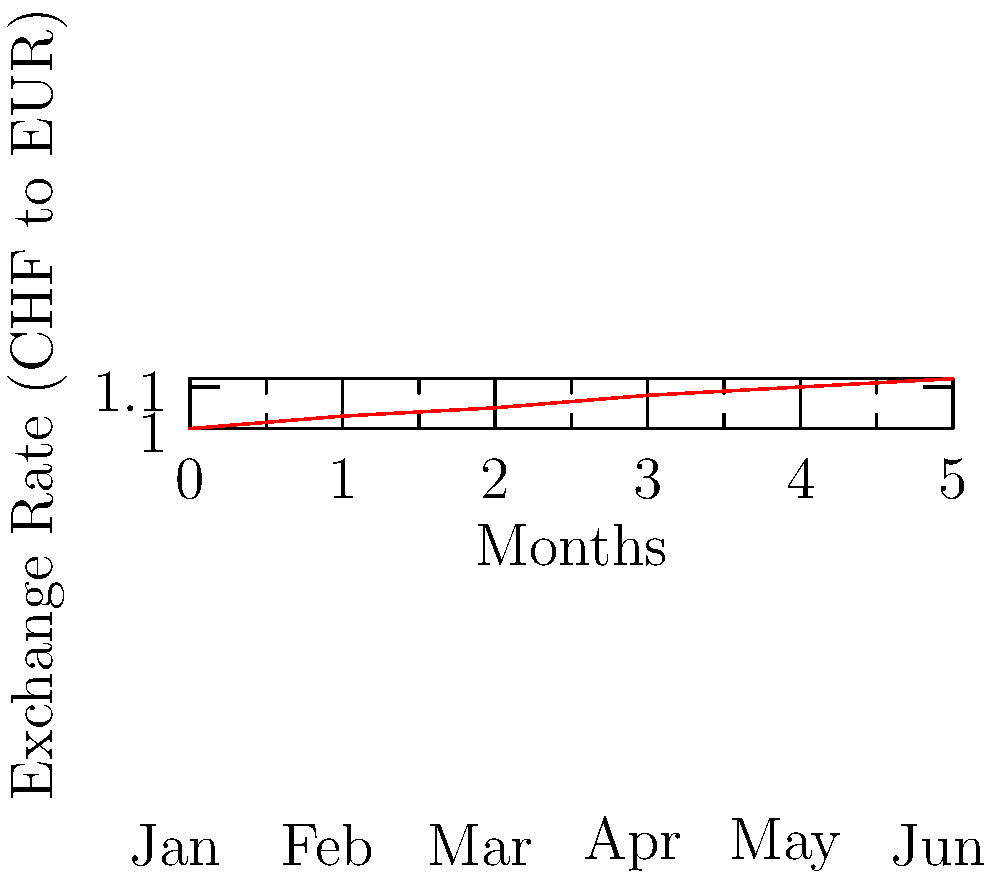The line graph shows the exchange rate between Swiss Francs (CHF) and Euros (EUR) over six months. If you exchanged 1000 CHF in January and the same amount in June, how many more Euros would you receive in June compared to January? To solve this problem, we need to follow these steps:

1. Identify the exchange rates:
   - January (start): 1 CHF = 1.00 EUR
   - June (end): 1 CHF = 1.12 EUR

2. Calculate the Euro amount for 1000 CHF in January:
   $1000 \times 1.00 = 1000$ EUR

3. Calculate the Euro amount for 1000 CHF in June:
   $1000 \times 1.12 = 1120$ EUR

4. Find the difference between June and January:
   $1120 - 1000 = 120$ EUR

Therefore, you would receive 120 more Euros in June compared to January when exchanging 1000 CHF.
Answer: 120 EUR 